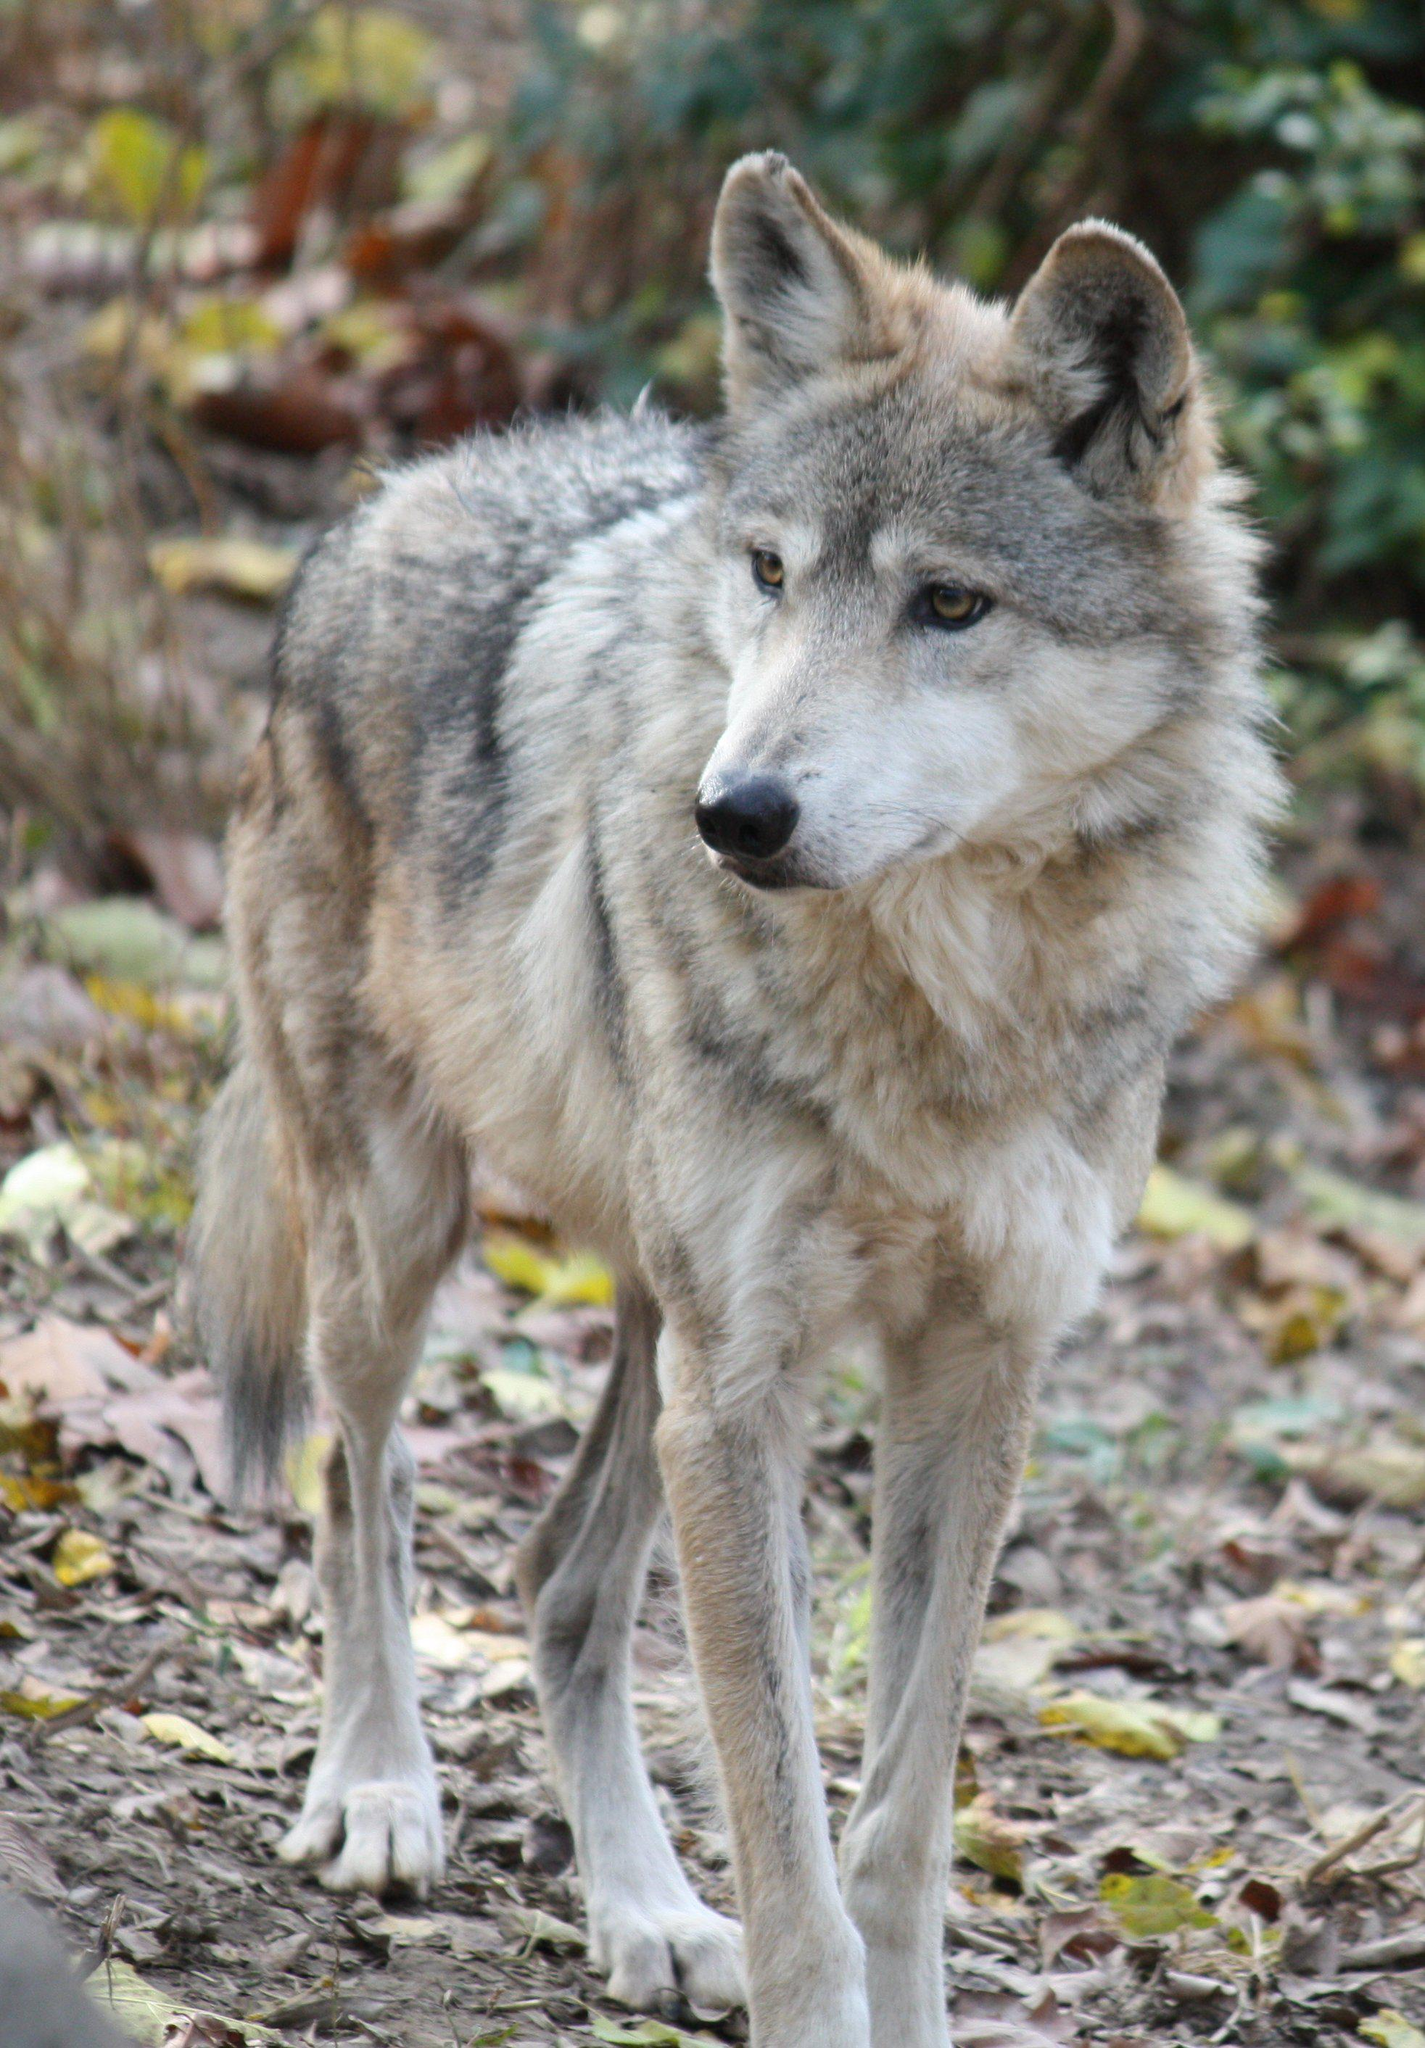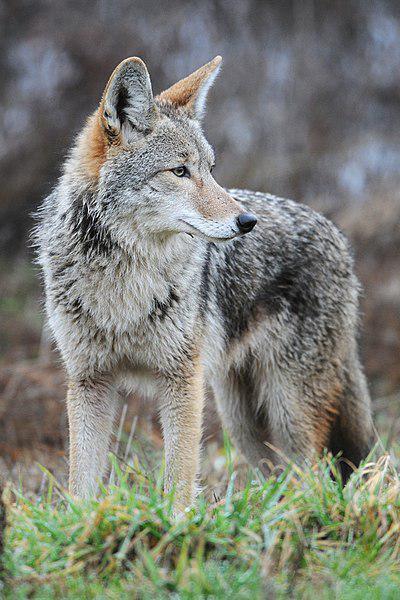The first image is the image on the left, the second image is the image on the right. Given the left and right images, does the statement "Two wolves are hanging out together in one of the pictures." hold true? Answer yes or no. No. The first image is the image on the left, the second image is the image on the right. Examine the images to the left and right. Is the description "One image contains twice as many wolves as the other image." accurate? Answer yes or no. No. 